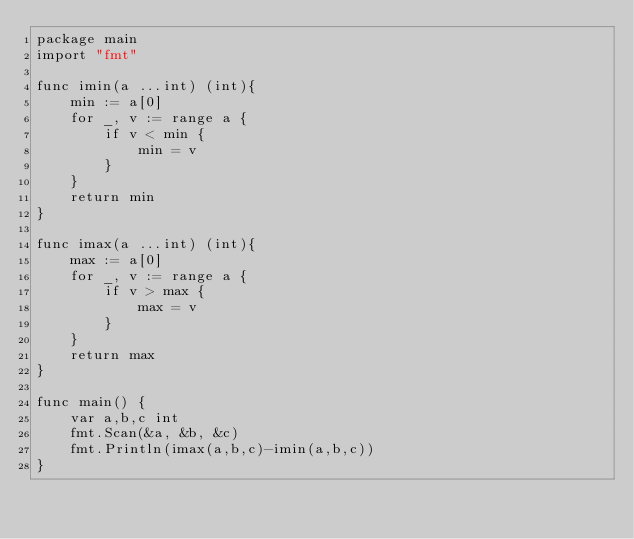Convert code to text. <code><loc_0><loc_0><loc_500><loc_500><_Go_>package main
import "fmt"

func imin(a ...int) (int){
	min := a[0]
    for _, v := range a {
        if v < min {
            min = v
        }
    }
    return min
}

func imax(a ...int) (int){
	max := a[0]
    for _, v := range a {
        if v > max {
            max = v
        }
    }
    return max
}

func main() {
	var a,b,c int
	fmt.Scan(&a, &b, &c)
	fmt.Println(imax(a,b,c)-imin(a,b,c))
}</code> 